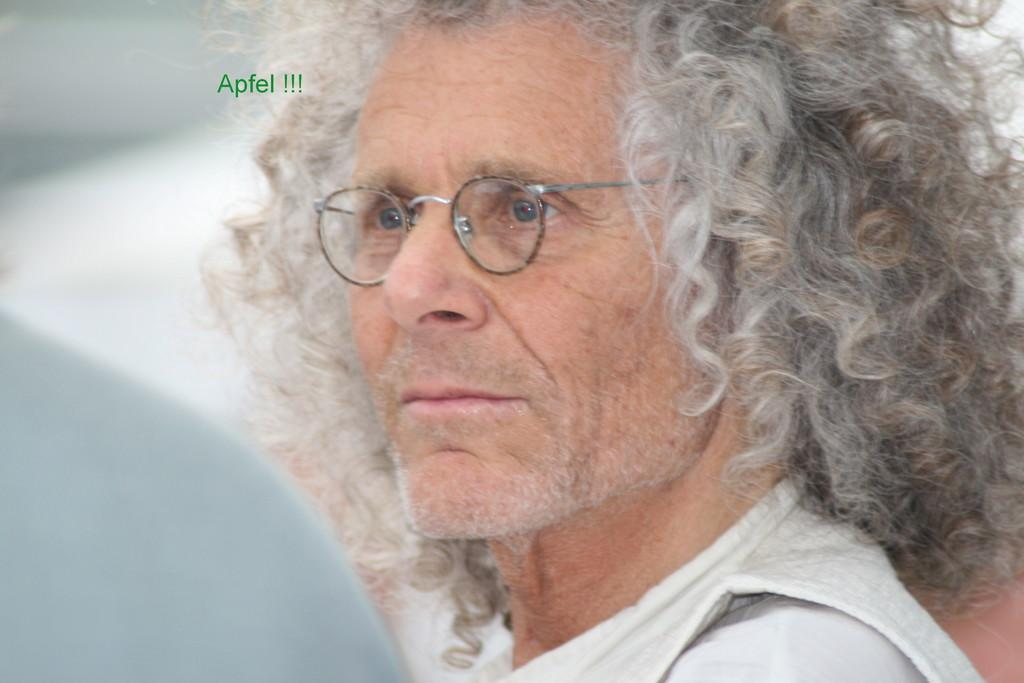Who is the main subject in the image? The main subject in the image is an old man. What is the old man wearing? The old man is wearing a white dress. What accessory is the old man wearing? The old man is wearing spectacles. How would you describe the old man's hair? The old man has white curly hair. Can you describe the background of the image? The background of the man is blurred. What event is the old man attending in the image? There is no indication of an event in the image; it simply features the old man. Who is the parent of the old man in the image? There is no information about the old man's parents in the image. 